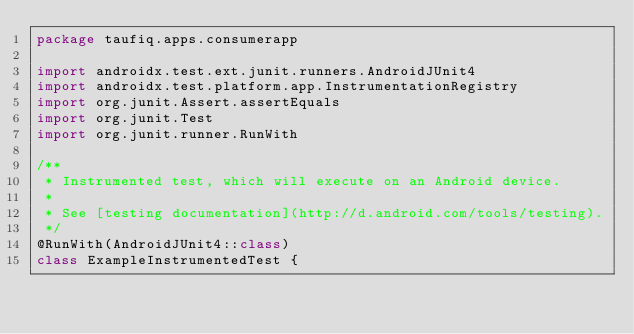Convert code to text. <code><loc_0><loc_0><loc_500><loc_500><_Kotlin_>package taufiq.apps.consumerapp

import androidx.test.ext.junit.runners.AndroidJUnit4
import androidx.test.platform.app.InstrumentationRegistry
import org.junit.Assert.assertEquals
import org.junit.Test
import org.junit.runner.RunWith

/**
 * Instrumented test, which will execute on an Android device.
 *
 * See [testing documentation](http://d.android.com/tools/testing).
 */
@RunWith(AndroidJUnit4::class)
class ExampleInstrumentedTest {</code> 